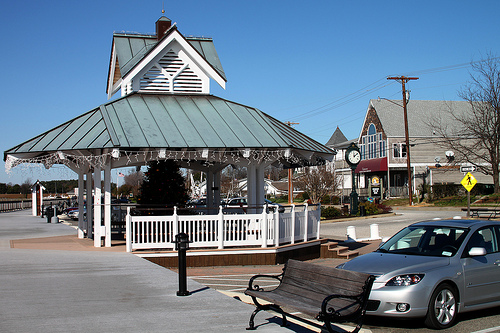Please provide the bounding box coordinate of the region this sentence describes: branches of a tree. The bounding box coordinates for the branches of a tree are approximately [0.93, 0.4, 0.97, 0.42]. These coordinates pinpoint the precise location of the tree branches within the image. 